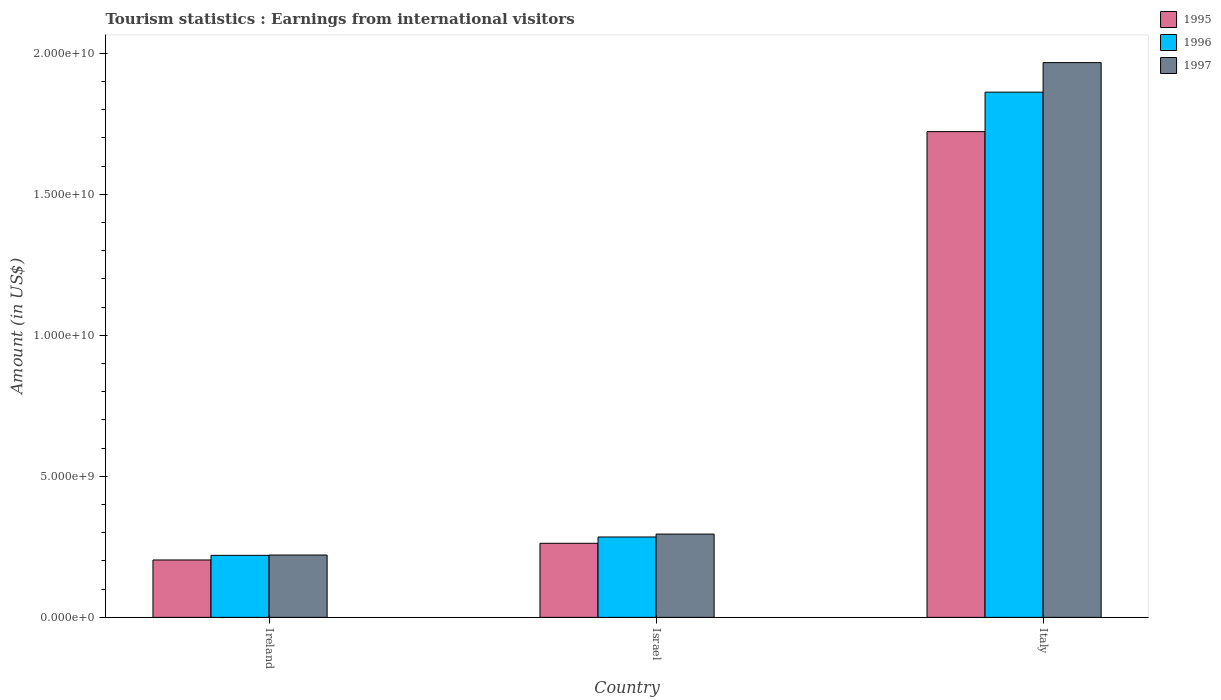How many different coloured bars are there?
Keep it short and to the point. 3. Are the number of bars on each tick of the X-axis equal?
Your answer should be very brief. Yes. How many bars are there on the 1st tick from the right?
Your response must be concise. 3. What is the label of the 2nd group of bars from the left?
Your answer should be compact. Israel. What is the earnings from international visitors in 1997 in Ireland?
Keep it short and to the point. 2.21e+09. Across all countries, what is the maximum earnings from international visitors in 1997?
Make the answer very short. 1.97e+1. Across all countries, what is the minimum earnings from international visitors in 1996?
Give a very brief answer. 2.20e+09. In which country was the earnings from international visitors in 1996 maximum?
Your response must be concise. Italy. In which country was the earnings from international visitors in 1995 minimum?
Give a very brief answer. Ireland. What is the total earnings from international visitors in 1995 in the graph?
Ensure brevity in your answer.  2.19e+1. What is the difference between the earnings from international visitors in 1996 in Ireland and that in Israel?
Offer a very short reply. -6.51e+08. What is the difference between the earnings from international visitors in 1995 in Italy and the earnings from international visitors in 1996 in Israel?
Ensure brevity in your answer.  1.44e+1. What is the average earnings from international visitors in 1996 per country?
Provide a succinct answer. 7.89e+09. What is the difference between the earnings from international visitors of/in 1996 and earnings from international visitors of/in 1995 in Italy?
Make the answer very short. 1.40e+09. In how many countries, is the earnings from international visitors in 1996 greater than 17000000000 US$?
Keep it short and to the point. 1. What is the ratio of the earnings from international visitors in 1995 in Ireland to that in Italy?
Make the answer very short. 0.12. Is the earnings from international visitors in 1996 in Ireland less than that in Israel?
Provide a short and direct response. Yes. What is the difference between the highest and the second highest earnings from international visitors in 1996?
Offer a terse response. 1.58e+1. What is the difference between the highest and the lowest earnings from international visitors in 1995?
Provide a short and direct response. 1.52e+1. In how many countries, is the earnings from international visitors in 1997 greater than the average earnings from international visitors in 1997 taken over all countries?
Provide a short and direct response. 1. Is the sum of the earnings from international visitors in 1997 in Ireland and Israel greater than the maximum earnings from international visitors in 1995 across all countries?
Give a very brief answer. No. What does the 3rd bar from the left in Israel represents?
Provide a succinct answer. 1997. What does the 1st bar from the right in Ireland represents?
Provide a short and direct response. 1997. How many bars are there?
Give a very brief answer. 9. How many countries are there in the graph?
Give a very brief answer. 3. What is the difference between two consecutive major ticks on the Y-axis?
Offer a very short reply. 5.00e+09. Are the values on the major ticks of Y-axis written in scientific E-notation?
Keep it short and to the point. Yes. Does the graph contain any zero values?
Provide a succinct answer. No. How many legend labels are there?
Offer a very short reply. 3. What is the title of the graph?
Offer a terse response. Tourism statistics : Earnings from international visitors. What is the Amount (in US$) in 1995 in Ireland?
Make the answer very short. 2.03e+09. What is the Amount (in US$) of 1996 in Ireland?
Your answer should be compact. 2.20e+09. What is the Amount (in US$) in 1997 in Ireland?
Your answer should be compact. 2.21e+09. What is the Amount (in US$) of 1995 in Israel?
Offer a terse response. 2.63e+09. What is the Amount (in US$) in 1996 in Israel?
Keep it short and to the point. 2.85e+09. What is the Amount (in US$) of 1997 in Israel?
Your answer should be very brief. 2.95e+09. What is the Amount (in US$) of 1995 in Italy?
Give a very brief answer. 1.72e+1. What is the Amount (in US$) of 1996 in Italy?
Your response must be concise. 1.86e+1. What is the Amount (in US$) in 1997 in Italy?
Keep it short and to the point. 1.97e+1. Across all countries, what is the maximum Amount (in US$) of 1995?
Your answer should be compact. 1.72e+1. Across all countries, what is the maximum Amount (in US$) of 1996?
Your answer should be very brief. 1.86e+1. Across all countries, what is the maximum Amount (in US$) in 1997?
Your answer should be very brief. 1.97e+1. Across all countries, what is the minimum Amount (in US$) of 1995?
Offer a very short reply. 2.03e+09. Across all countries, what is the minimum Amount (in US$) in 1996?
Keep it short and to the point. 2.20e+09. Across all countries, what is the minimum Amount (in US$) in 1997?
Your response must be concise. 2.21e+09. What is the total Amount (in US$) in 1995 in the graph?
Your answer should be very brief. 2.19e+1. What is the total Amount (in US$) in 1996 in the graph?
Your answer should be compact. 2.37e+1. What is the total Amount (in US$) in 1997 in the graph?
Make the answer very short. 2.48e+1. What is the difference between the Amount (in US$) in 1995 in Ireland and that in Israel?
Your response must be concise. -5.92e+08. What is the difference between the Amount (in US$) of 1996 in Ireland and that in Israel?
Provide a succinct answer. -6.51e+08. What is the difference between the Amount (in US$) in 1997 in Ireland and that in Israel?
Your answer should be very brief. -7.42e+08. What is the difference between the Amount (in US$) of 1995 in Ireland and that in Italy?
Offer a terse response. -1.52e+1. What is the difference between the Amount (in US$) of 1996 in Ireland and that in Italy?
Give a very brief answer. -1.64e+1. What is the difference between the Amount (in US$) of 1997 in Ireland and that in Italy?
Offer a terse response. -1.75e+1. What is the difference between the Amount (in US$) of 1995 in Israel and that in Italy?
Offer a very short reply. -1.46e+1. What is the difference between the Amount (in US$) in 1996 in Israel and that in Italy?
Your answer should be compact. -1.58e+1. What is the difference between the Amount (in US$) in 1997 in Israel and that in Italy?
Ensure brevity in your answer.  -1.67e+1. What is the difference between the Amount (in US$) of 1995 in Ireland and the Amount (in US$) of 1996 in Israel?
Ensure brevity in your answer.  -8.15e+08. What is the difference between the Amount (in US$) in 1995 in Ireland and the Amount (in US$) in 1997 in Israel?
Keep it short and to the point. -9.18e+08. What is the difference between the Amount (in US$) of 1996 in Ireland and the Amount (in US$) of 1997 in Israel?
Offer a very short reply. -7.54e+08. What is the difference between the Amount (in US$) of 1995 in Ireland and the Amount (in US$) of 1996 in Italy?
Your answer should be very brief. -1.66e+1. What is the difference between the Amount (in US$) in 1995 in Ireland and the Amount (in US$) in 1997 in Italy?
Make the answer very short. -1.76e+1. What is the difference between the Amount (in US$) of 1996 in Ireland and the Amount (in US$) of 1997 in Italy?
Keep it short and to the point. -1.75e+1. What is the difference between the Amount (in US$) of 1995 in Israel and the Amount (in US$) of 1996 in Italy?
Keep it short and to the point. -1.60e+1. What is the difference between the Amount (in US$) in 1995 in Israel and the Amount (in US$) in 1997 in Italy?
Your response must be concise. -1.70e+1. What is the difference between the Amount (in US$) of 1996 in Israel and the Amount (in US$) of 1997 in Italy?
Ensure brevity in your answer.  -1.68e+1. What is the average Amount (in US$) of 1995 per country?
Keep it short and to the point. 7.29e+09. What is the average Amount (in US$) of 1996 per country?
Ensure brevity in your answer.  7.89e+09. What is the average Amount (in US$) of 1997 per country?
Your answer should be very brief. 8.28e+09. What is the difference between the Amount (in US$) of 1995 and Amount (in US$) of 1996 in Ireland?
Offer a very short reply. -1.64e+08. What is the difference between the Amount (in US$) of 1995 and Amount (in US$) of 1997 in Ireland?
Offer a terse response. -1.76e+08. What is the difference between the Amount (in US$) in 1996 and Amount (in US$) in 1997 in Ireland?
Make the answer very short. -1.20e+07. What is the difference between the Amount (in US$) of 1995 and Amount (in US$) of 1996 in Israel?
Offer a terse response. -2.23e+08. What is the difference between the Amount (in US$) in 1995 and Amount (in US$) in 1997 in Israel?
Provide a succinct answer. -3.26e+08. What is the difference between the Amount (in US$) of 1996 and Amount (in US$) of 1997 in Israel?
Provide a short and direct response. -1.03e+08. What is the difference between the Amount (in US$) of 1995 and Amount (in US$) of 1996 in Italy?
Your answer should be compact. -1.40e+09. What is the difference between the Amount (in US$) in 1995 and Amount (in US$) in 1997 in Italy?
Your answer should be compact. -2.45e+09. What is the difference between the Amount (in US$) in 1996 and Amount (in US$) in 1997 in Italy?
Make the answer very short. -1.05e+09. What is the ratio of the Amount (in US$) in 1995 in Ireland to that in Israel?
Keep it short and to the point. 0.77. What is the ratio of the Amount (in US$) of 1996 in Ireland to that in Israel?
Your response must be concise. 0.77. What is the ratio of the Amount (in US$) in 1997 in Ireland to that in Israel?
Your answer should be compact. 0.75. What is the ratio of the Amount (in US$) of 1995 in Ireland to that in Italy?
Offer a very short reply. 0.12. What is the ratio of the Amount (in US$) in 1996 in Ireland to that in Italy?
Your response must be concise. 0.12. What is the ratio of the Amount (in US$) in 1997 in Ireland to that in Italy?
Your response must be concise. 0.11. What is the ratio of the Amount (in US$) in 1995 in Israel to that in Italy?
Give a very brief answer. 0.15. What is the ratio of the Amount (in US$) in 1996 in Israel to that in Italy?
Provide a succinct answer. 0.15. What is the ratio of the Amount (in US$) in 1997 in Israel to that in Italy?
Keep it short and to the point. 0.15. What is the difference between the highest and the second highest Amount (in US$) in 1995?
Ensure brevity in your answer.  1.46e+1. What is the difference between the highest and the second highest Amount (in US$) of 1996?
Provide a short and direct response. 1.58e+1. What is the difference between the highest and the second highest Amount (in US$) of 1997?
Make the answer very short. 1.67e+1. What is the difference between the highest and the lowest Amount (in US$) in 1995?
Provide a short and direct response. 1.52e+1. What is the difference between the highest and the lowest Amount (in US$) of 1996?
Your response must be concise. 1.64e+1. What is the difference between the highest and the lowest Amount (in US$) in 1997?
Your answer should be very brief. 1.75e+1. 